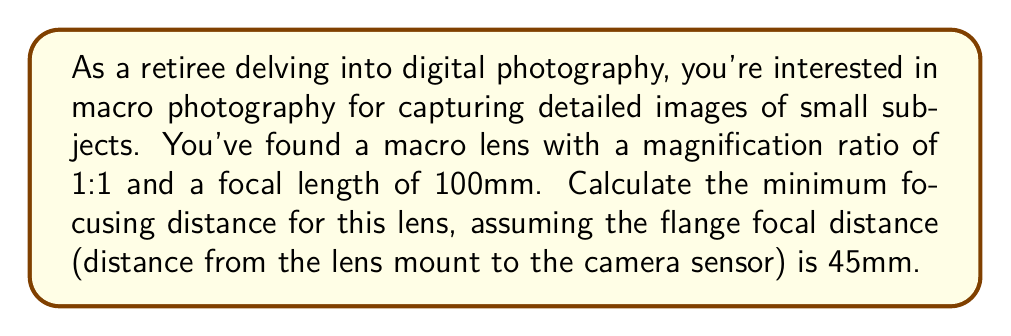Could you help me with this problem? To calculate the minimum focusing distance for a macro lens, we need to use the following formula:

$$ MFD = f \cdot (1 + \frac{1}{m}) + FFD $$

Where:
- $MFD$ is the Minimum Focusing Distance
- $f$ is the focal length of the lens
- $m$ is the magnification ratio
- $FFD$ is the Flange Focal Distance

Given:
- Focal length, $f = 100mm$
- Magnification ratio, $m = 1:1 = 1$
- Flange Focal Distance, $FFD = 45mm$

Let's substitute these values into our formula:

$$ MFD = 100 \cdot (1 + \frac{1}{1}) + 45 $$

$$ MFD = 100 \cdot (1 + 1) + 45 $$

$$ MFD = 100 \cdot 2 + 45 $$

$$ MFD = 200 + 45 $$

$$ MFD = 245mm $$

Therefore, the minimum focusing distance for this macro lens is 245mm or 24.5cm.
Answer: The minimum focusing distance for the macro lens is 245mm or 24.5cm. 